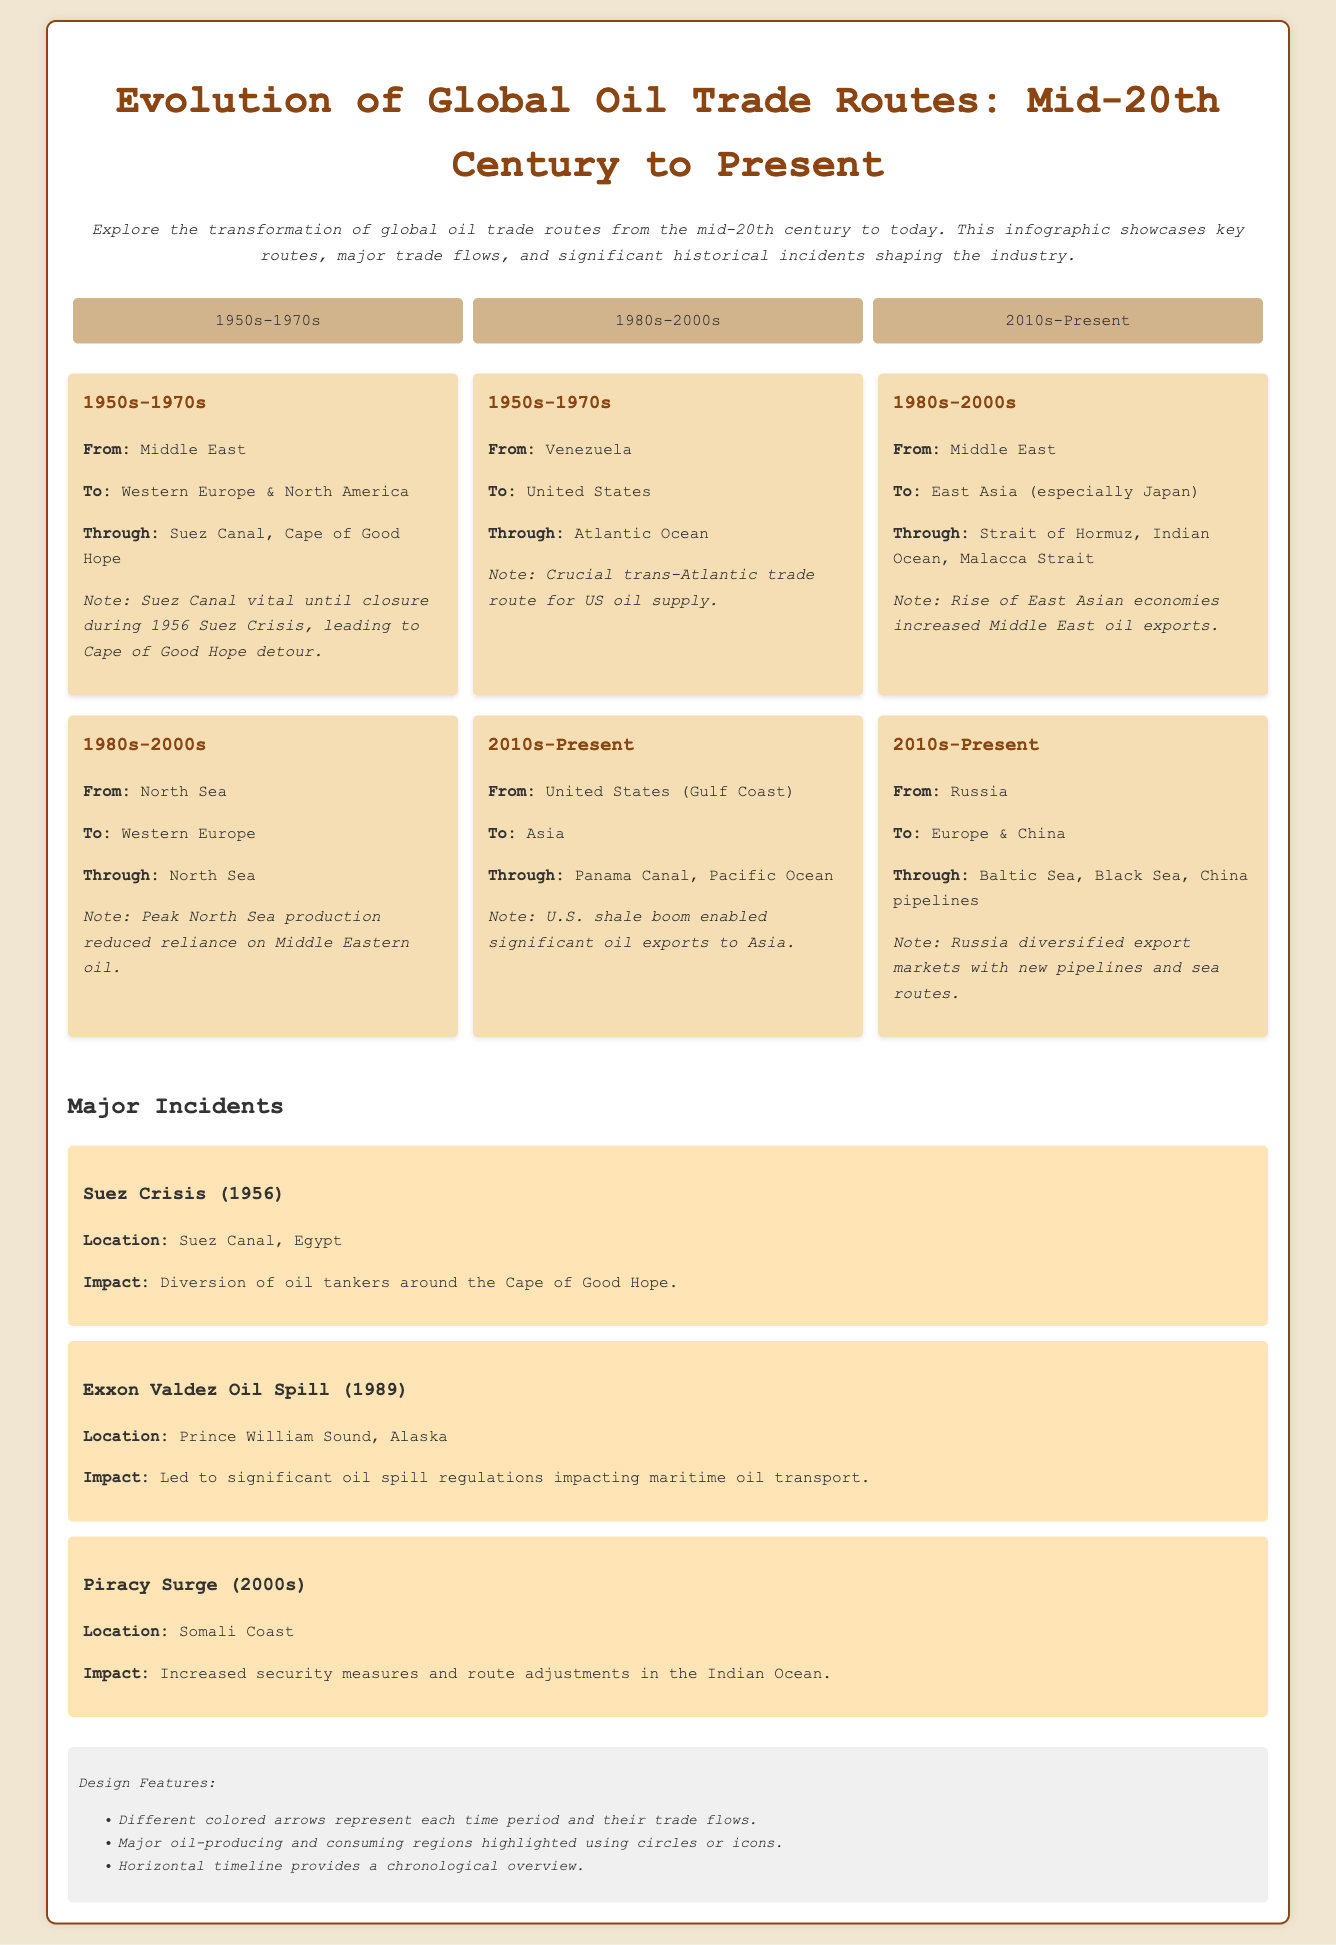What trade route was crucial for the US oil supply in the 1950s-1970s? The route from Venezuela to the United States is highlighted as a crucial trade route for US oil supply during that period.
Answer: Venezuela to United States Which major incident occurred in 1956? The Suez Crisis is mentioned as a significant event that impacted oil trade routes by leading to the diversion of oil tankers.
Answer: Suez Crisis What geographical feature became vital for oil transport during the 1950s-1970s? The Suez Canal was noted as a vital route until its closure during the Suez Crisis.
Answer: Suez Canal In which decade did the United States start significantly exporting oil to Asia? The 2010s is indicated as the period when US oil exports to Asia increased due to the shale boom.
Answer: 2010s What does the infographic note about Middle East oil exports in the 1980s-2000s? The rise of East Asian economies led to increased exports from the Middle East to East Asia.
Answer: Increased exports Which region's production peaked in the 1980s-2000s, reducing reliance on Middle Eastern oil? North Sea production peaked during this period, leading to reduced dependence on Middle Eastern oil.
Answer: North Sea What is indicated as a significant consequence of the Exxon Valdez Oil Spill? The spill resulted in the implementation of significant oil spill regulations impacting maritime oil transport.
Answer: Oil spill regulations What type of design features are used to represent trade flows in the infographic? Different colored arrows are used to signify trade flows for each time period represented in the infographic.
Answer: Different colored arrows 